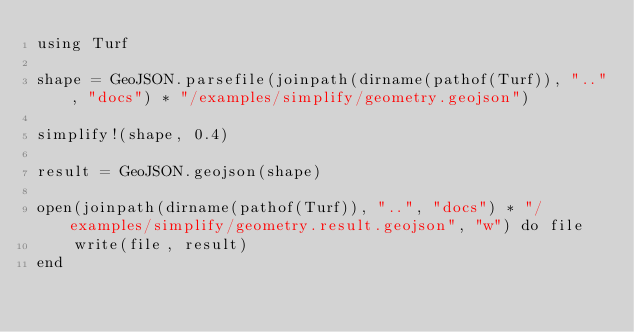Convert code to text. <code><loc_0><loc_0><loc_500><loc_500><_Julia_>using Turf

shape = GeoJSON.parsefile(joinpath(dirname(pathof(Turf)), "..", "docs") * "/examples/simplify/geometry.geojson")

simplify!(shape, 0.4)

result = GeoJSON.geojson(shape)

open(joinpath(dirname(pathof(Turf)), "..", "docs") * "/examples/simplify/geometry.result.geojson", "w") do file
    write(file, result)
end
</code> 